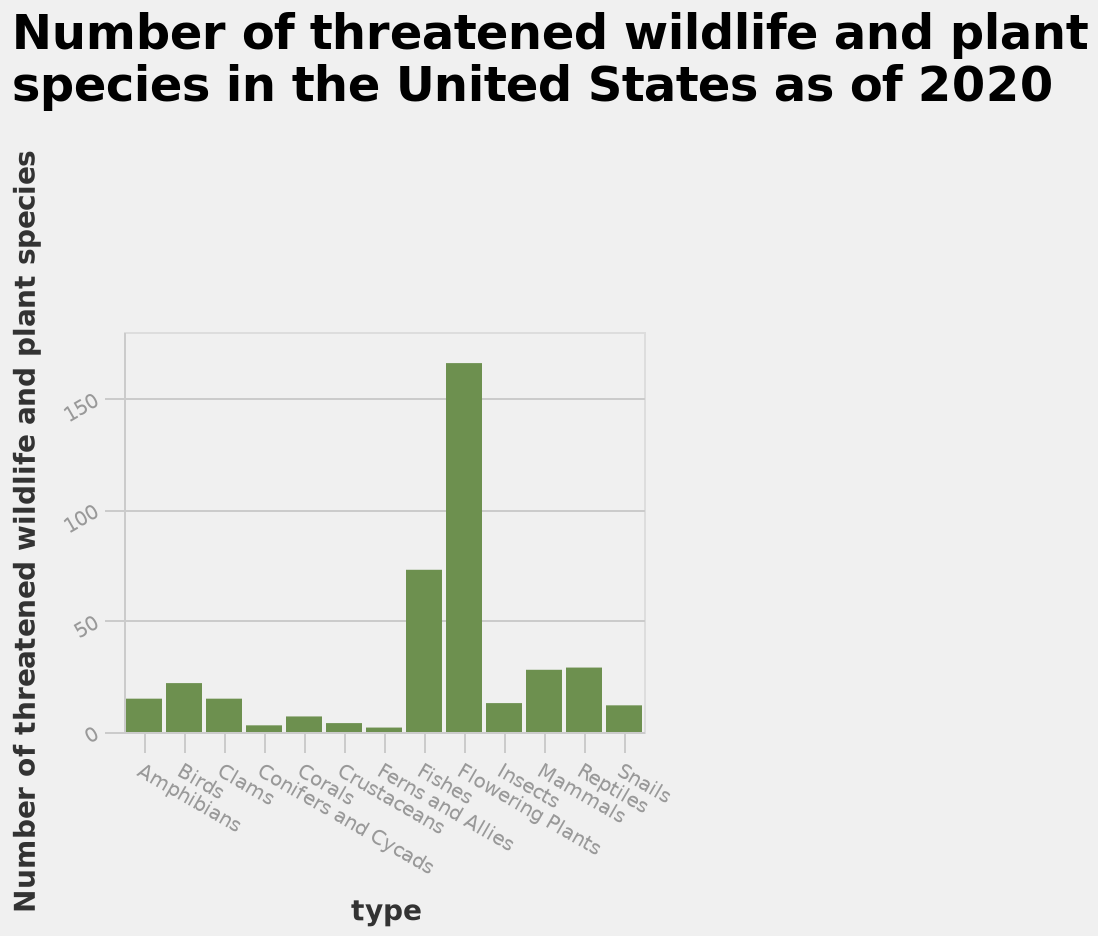<image>
What is the highest number of threatened wildlife and plant species on the y-axis?  The highest number of threatened wildlife and plant species is 150. How many species of flowering plants are threatened?  Over 150 species. How many species of fishes are threatened?  Over 50 species. What type of species is represented by the first category on the x-axis?  The first category on the x-axis represents Amphibians. Is the highest number of threatened wildlife and plant species 200? No. The highest number of threatened wildlife and plant species is 150. 